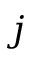<formula> <loc_0><loc_0><loc_500><loc_500>j</formula> 